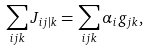<formula> <loc_0><loc_0><loc_500><loc_500>\sum _ { i j k } J _ { i j | k } = \sum _ { i j k } \alpha _ { i } g _ { j k } ,</formula> 